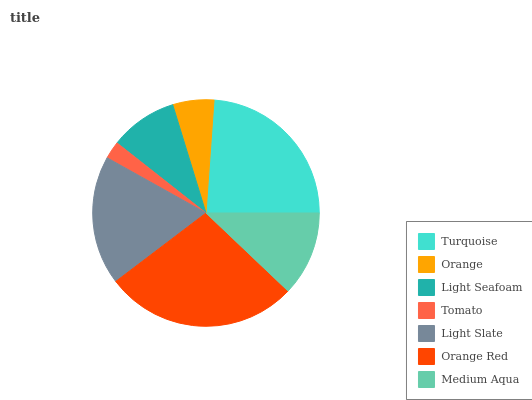Is Tomato the minimum?
Answer yes or no. Yes. Is Orange Red the maximum?
Answer yes or no. Yes. Is Orange the minimum?
Answer yes or no. No. Is Orange the maximum?
Answer yes or no. No. Is Turquoise greater than Orange?
Answer yes or no. Yes. Is Orange less than Turquoise?
Answer yes or no. Yes. Is Orange greater than Turquoise?
Answer yes or no. No. Is Turquoise less than Orange?
Answer yes or no. No. Is Medium Aqua the high median?
Answer yes or no. Yes. Is Medium Aqua the low median?
Answer yes or no. Yes. Is Light Slate the high median?
Answer yes or no. No. Is Orange Red the low median?
Answer yes or no. No. 